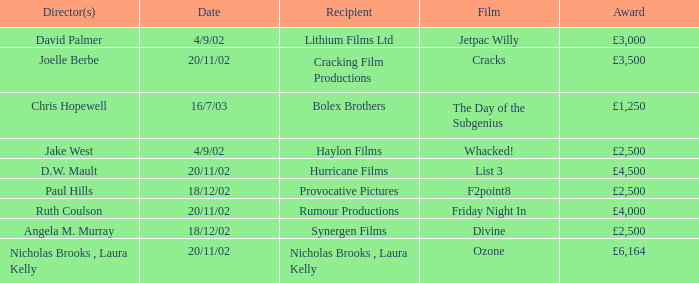Who directed a film for Cracking Film Productions? Joelle Berbe. 